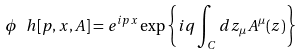Convert formula to latex. <formula><loc_0><loc_0><loc_500><loc_500>\phi _ { \ } h [ p , x , A ] = e ^ { i p x } \exp \left \{ i q \int _ { C } d z _ { \mu } A ^ { \mu } ( z ) \right \}</formula> 